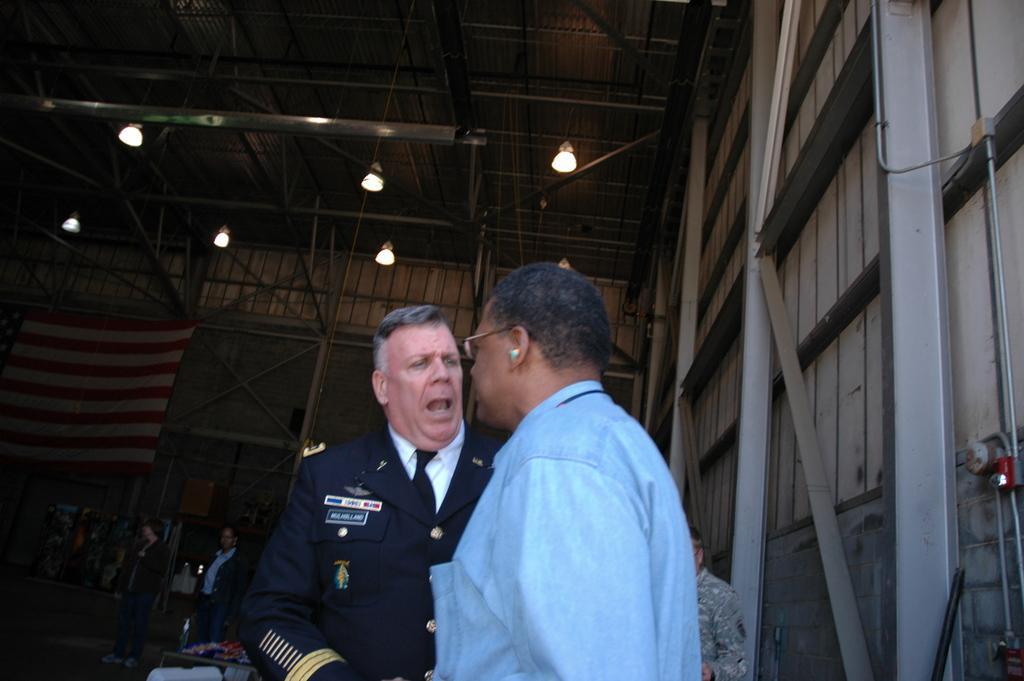In one or two sentences, can you explain what this image depicts? In this image we can see two persons in the foreground. Behind the persons we can see few more persons and a flag. At the top we can see a roof and lights. On the right side, we can see a wall and a few objects. 